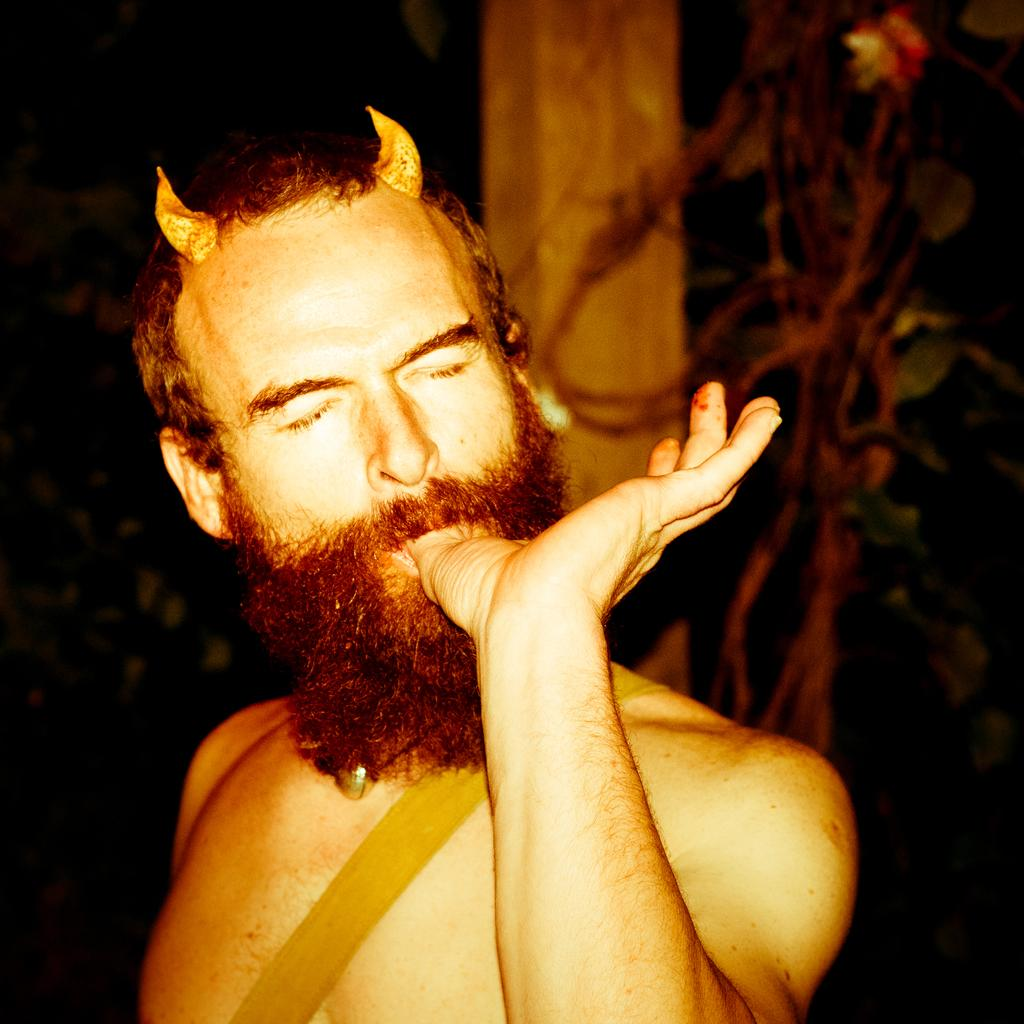What is the main subject of the image? There is a person in the image. What is the person doing in the image? The person has their finger in their mouth. What type of berry is the person holding in the image? There is no berry present in the image; the person has their finger in their mouth. What is the person's occupation as a governor in the image? There is no indication of the person's occupation or title in the image. 